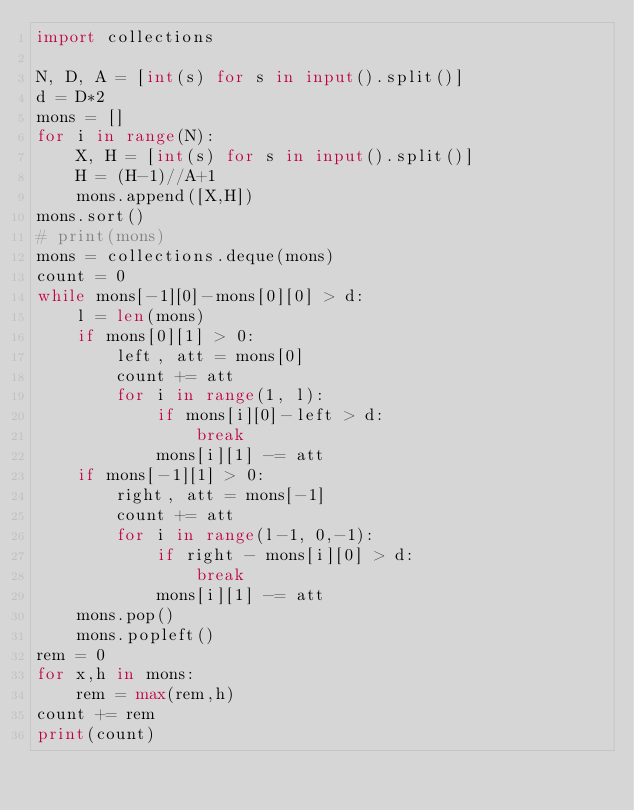<code> <loc_0><loc_0><loc_500><loc_500><_Python_>import collections

N, D, A = [int(s) for s in input().split()]
d = D*2
mons = []
for i in range(N):
    X, H = [int(s) for s in input().split()]
    H = (H-1)//A+1
    mons.append([X,H])
mons.sort()
# print(mons)
mons = collections.deque(mons)
count = 0
while mons[-1][0]-mons[0][0] > d:
    l = len(mons)
    if mons[0][1] > 0:
        left, att = mons[0]
        count += att
        for i in range(1, l):
            if mons[i][0]-left > d:
                break
            mons[i][1] -= att
    if mons[-1][1] > 0:
        right, att = mons[-1]
        count += att
        for i in range(l-1, 0,-1):
            if right - mons[i][0] > d:
                break
            mons[i][1] -= att
    mons.pop()
    mons.popleft()
rem = 0
for x,h in mons:
    rem = max(rem,h)
count += rem
print(count)</code> 